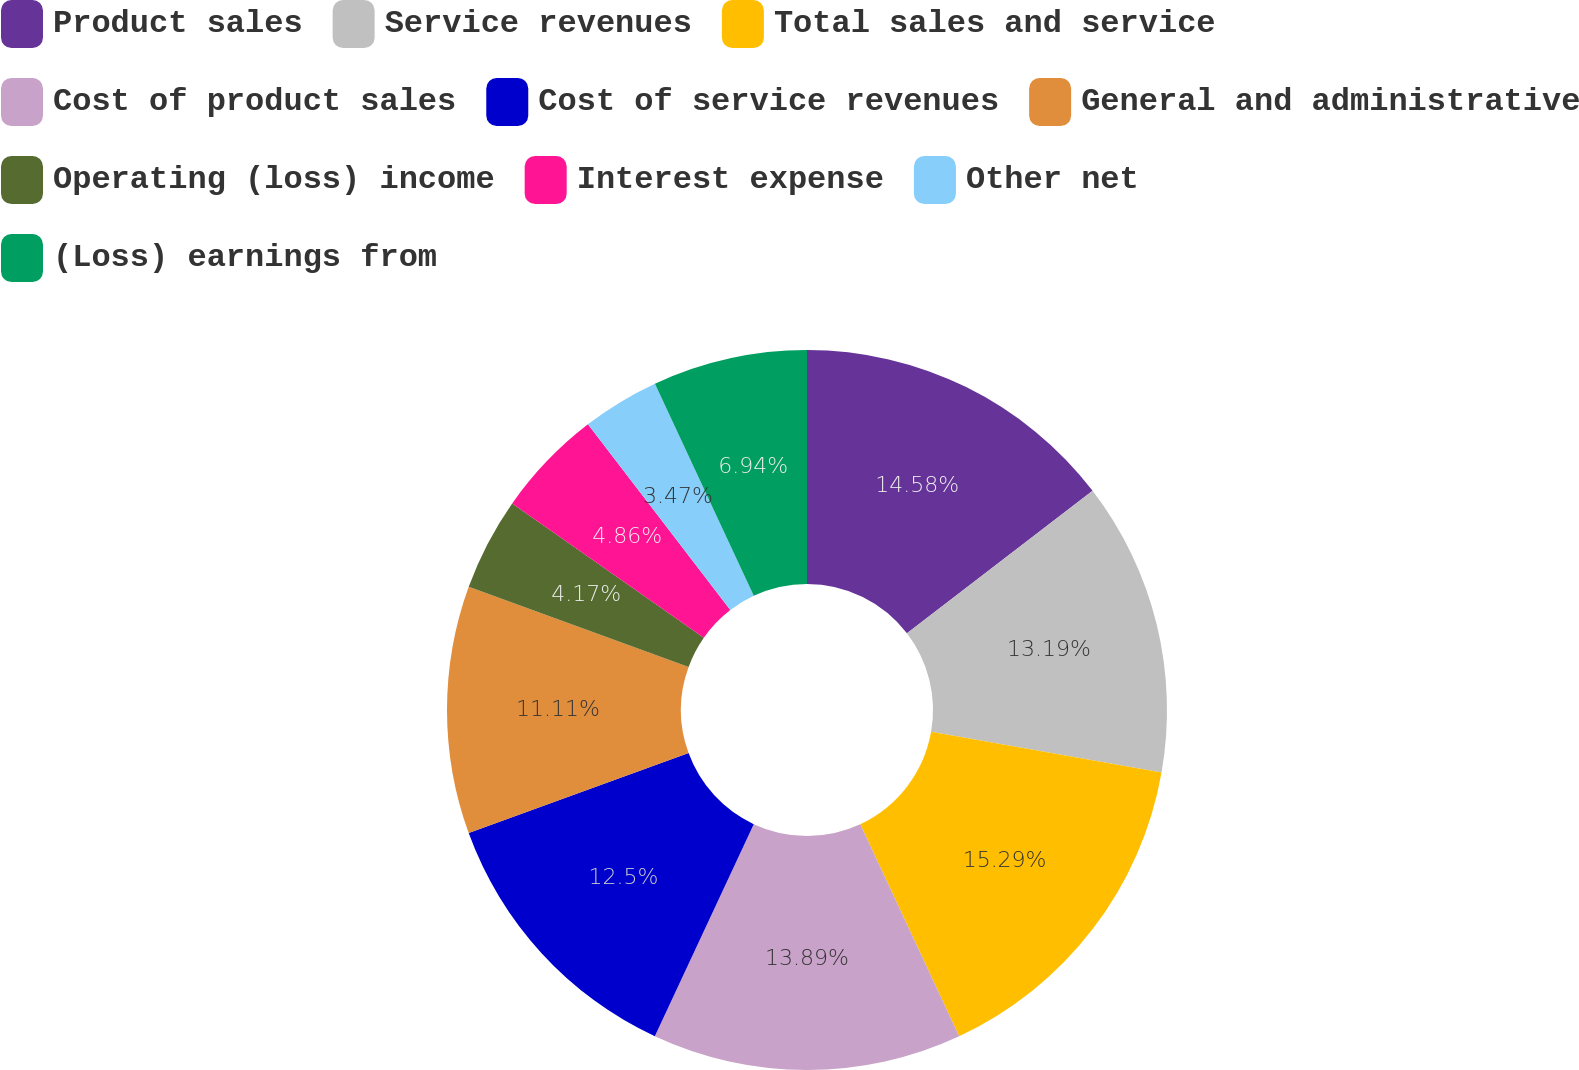<chart> <loc_0><loc_0><loc_500><loc_500><pie_chart><fcel>Product sales<fcel>Service revenues<fcel>Total sales and service<fcel>Cost of product sales<fcel>Cost of service revenues<fcel>General and administrative<fcel>Operating (loss) income<fcel>Interest expense<fcel>Other net<fcel>(Loss) earnings from<nl><fcel>14.58%<fcel>13.19%<fcel>15.28%<fcel>13.89%<fcel>12.5%<fcel>11.11%<fcel>4.17%<fcel>4.86%<fcel>3.47%<fcel>6.94%<nl></chart> 